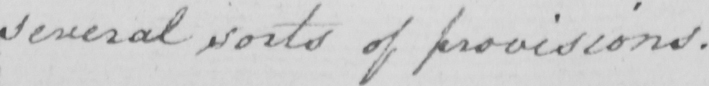What text is written in this handwritten line? several sorts of provisions . 